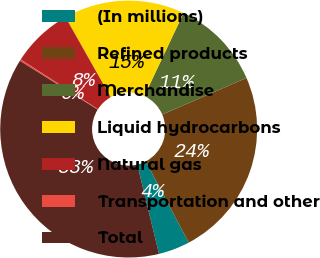<chart> <loc_0><loc_0><loc_500><loc_500><pie_chart><fcel>(In millions)<fcel>Refined products<fcel>Merchandise<fcel>Liquid hydrocarbons<fcel>Natural gas<fcel>Transportation and other<fcel>Total<nl><fcel>3.95%<fcel>23.77%<fcel>11.45%<fcel>15.21%<fcel>7.7%<fcel>0.2%<fcel>37.71%<nl></chart> 